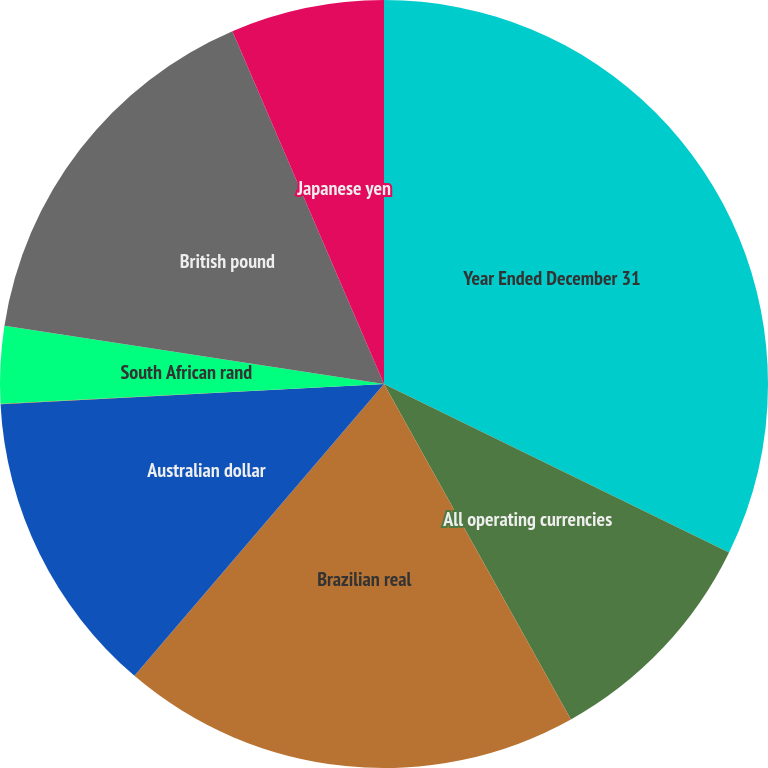<chart> <loc_0><loc_0><loc_500><loc_500><pie_chart><fcel>Year Ended December 31<fcel>All operating currencies<fcel>Brazilian real<fcel>Australian dollar<fcel>Euro<fcel>South African rand<fcel>British pound<fcel>Japanese yen<nl><fcel>32.23%<fcel>9.68%<fcel>19.35%<fcel>12.9%<fcel>0.02%<fcel>3.24%<fcel>16.12%<fcel>6.46%<nl></chart> 